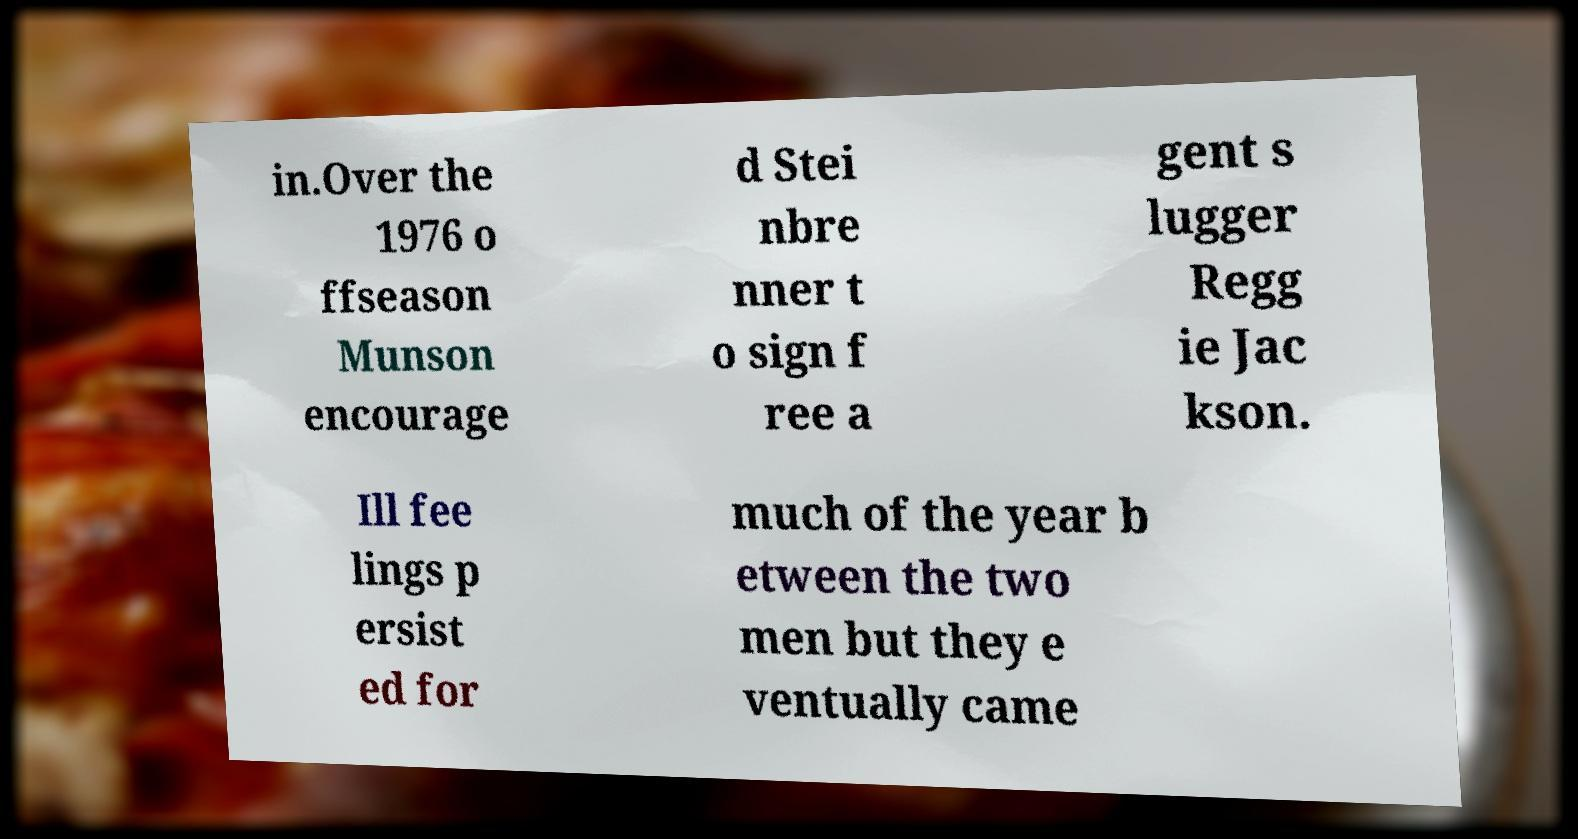What messages or text are displayed in this image? I need them in a readable, typed format. in.Over the 1976 o ffseason Munson encourage d Stei nbre nner t o sign f ree a gent s lugger Regg ie Jac kson. Ill fee lings p ersist ed for much of the year b etween the two men but they e ventually came 